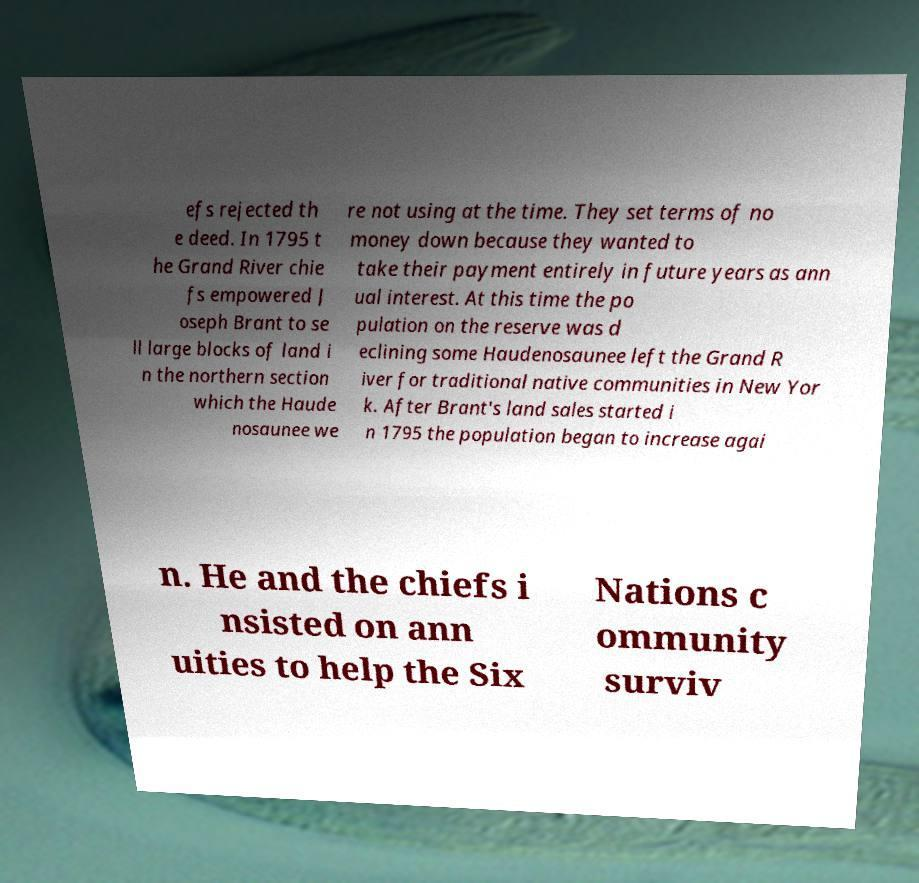I need the written content from this picture converted into text. Can you do that? efs rejected th e deed. In 1795 t he Grand River chie fs empowered J oseph Brant to se ll large blocks of land i n the northern section which the Haude nosaunee we re not using at the time. They set terms of no money down because they wanted to take their payment entirely in future years as ann ual interest. At this time the po pulation on the reserve was d eclining some Haudenosaunee left the Grand R iver for traditional native communities in New Yor k. After Brant's land sales started i n 1795 the population began to increase agai n. He and the chiefs i nsisted on ann uities to help the Six Nations c ommunity surviv 